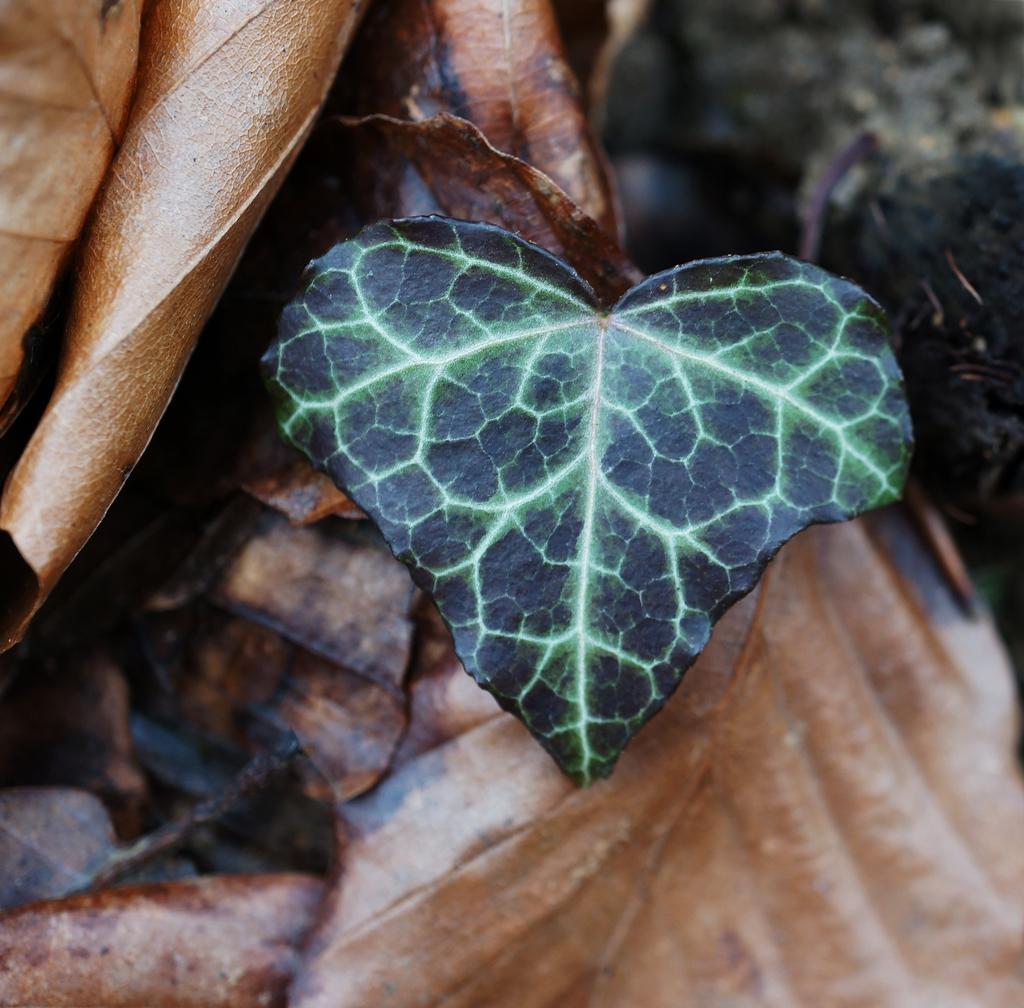Can you describe this image briefly? In this image I can see number of brown color leaves and in the front I can see a black and green colour thing. I can also see this image is little bit blurry. 